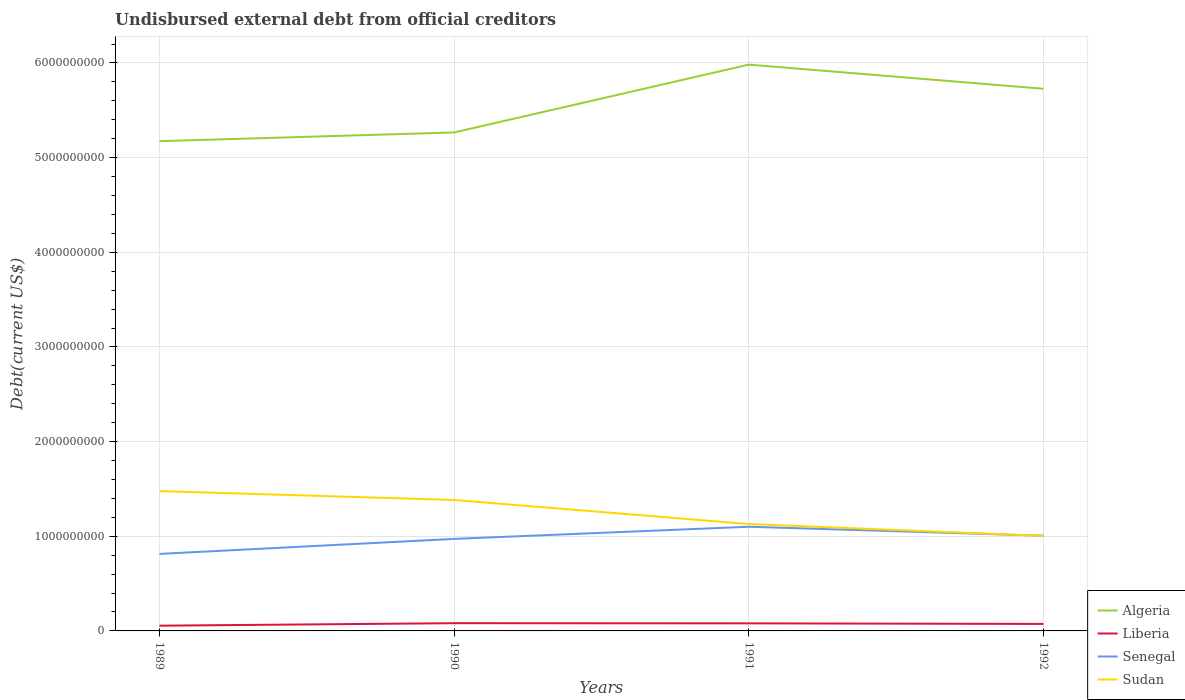Is the number of lines equal to the number of legend labels?
Make the answer very short. Yes. Across all years, what is the maximum total debt in Senegal?
Give a very brief answer. 8.14e+08. What is the total total debt in Senegal in the graph?
Ensure brevity in your answer.  -3.39e+07. What is the difference between the highest and the second highest total debt in Liberia?
Your answer should be compact. 2.63e+07. Is the total debt in Sudan strictly greater than the total debt in Senegal over the years?
Your answer should be very brief. No. Does the graph contain grids?
Offer a very short reply. Yes. Where does the legend appear in the graph?
Offer a very short reply. Bottom right. How are the legend labels stacked?
Offer a terse response. Vertical. What is the title of the graph?
Give a very brief answer. Undisbursed external debt from official creditors. Does "Micronesia" appear as one of the legend labels in the graph?
Your response must be concise. No. What is the label or title of the X-axis?
Offer a very short reply. Years. What is the label or title of the Y-axis?
Keep it short and to the point. Debt(current US$). What is the Debt(current US$) of Algeria in 1989?
Your answer should be very brief. 5.17e+09. What is the Debt(current US$) in Liberia in 1989?
Provide a succinct answer. 5.53e+07. What is the Debt(current US$) of Senegal in 1989?
Offer a very short reply. 8.14e+08. What is the Debt(current US$) of Sudan in 1989?
Give a very brief answer. 1.48e+09. What is the Debt(current US$) of Algeria in 1990?
Make the answer very short. 5.27e+09. What is the Debt(current US$) of Liberia in 1990?
Your response must be concise. 8.16e+07. What is the Debt(current US$) in Senegal in 1990?
Offer a very short reply. 9.72e+08. What is the Debt(current US$) of Sudan in 1990?
Provide a short and direct response. 1.38e+09. What is the Debt(current US$) in Algeria in 1991?
Offer a very short reply. 5.98e+09. What is the Debt(current US$) of Liberia in 1991?
Provide a short and direct response. 8.01e+07. What is the Debt(current US$) of Senegal in 1991?
Ensure brevity in your answer.  1.10e+09. What is the Debt(current US$) in Sudan in 1991?
Your response must be concise. 1.13e+09. What is the Debt(current US$) of Algeria in 1992?
Offer a very short reply. 5.73e+09. What is the Debt(current US$) in Liberia in 1992?
Keep it short and to the point. 7.37e+07. What is the Debt(current US$) of Senegal in 1992?
Provide a succinct answer. 1.01e+09. What is the Debt(current US$) in Sudan in 1992?
Make the answer very short. 1.00e+09. Across all years, what is the maximum Debt(current US$) in Algeria?
Ensure brevity in your answer.  5.98e+09. Across all years, what is the maximum Debt(current US$) of Liberia?
Ensure brevity in your answer.  8.16e+07. Across all years, what is the maximum Debt(current US$) in Senegal?
Your response must be concise. 1.10e+09. Across all years, what is the maximum Debt(current US$) in Sudan?
Your response must be concise. 1.48e+09. Across all years, what is the minimum Debt(current US$) in Algeria?
Ensure brevity in your answer.  5.17e+09. Across all years, what is the minimum Debt(current US$) of Liberia?
Offer a terse response. 5.53e+07. Across all years, what is the minimum Debt(current US$) of Senegal?
Your answer should be compact. 8.14e+08. Across all years, what is the minimum Debt(current US$) of Sudan?
Make the answer very short. 1.00e+09. What is the total Debt(current US$) in Algeria in the graph?
Your answer should be compact. 2.22e+1. What is the total Debt(current US$) in Liberia in the graph?
Keep it short and to the point. 2.91e+08. What is the total Debt(current US$) in Senegal in the graph?
Ensure brevity in your answer.  3.89e+09. What is the total Debt(current US$) of Sudan in the graph?
Make the answer very short. 4.99e+09. What is the difference between the Debt(current US$) in Algeria in 1989 and that in 1990?
Your answer should be very brief. -9.20e+07. What is the difference between the Debt(current US$) of Liberia in 1989 and that in 1990?
Ensure brevity in your answer.  -2.63e+07. What is the difference between the Debt(current US$) of Senegal in 1989 and that in 1990?
Ensure brevity in your answer.  -1.59e+08. What is the difference between the Debt(current US$) in Sudan in 1989 and that in 1990?
Provide a short and direct response. 9.43e+07. What is the difference between the Debt(current US$) in Algeria in 1989 and that in 1991?
Give a very brief answer. -8.09e+08. What is the difference between the Debt(current US$) of Liberia in 1989 and that in 1991?
Keep it short and to the point. -2.47e+07. What is the difference between the Debt(current US$) in Senegal in 1989 and that in 1991?
Provide a short and direct response. -2.87e+08. What is the difference between the Debt(current US$) in Sudan in 1989 and that in 1991?
Keep it short and to the point. 3.48e+08. What is the difference between the Debt(current US$) in Algeria in 1989 and that in 1992?
Keep it short and to the point. -5.54e+08. What is the difference between the Debt(current US$) in Liberia in 1989 and that in 1992?
Provide a succinct answer. -1.84e+07. What is the difference between the Debt(current US$) in Senegal in 1989 and that in 1992?
Offer a very short reply. -1.92e+08. What is the difference between the Debt(current US$) in Sudan in 1989 and that in 1992?
Make the answer very short. 4.74e+08. What is the difference between the Debt(current US$) of Algeria in 1990 and that in 1991?
Your answer should be compact. -7.17e+08. What is the difference between the Debt(current US$) of Liberia in 1990 and that in 1991?
Give a very brief answer. 1.58e+06. What is the difference between the Debt(current US$) in Senegal in 1990 and that in 1991?
Your answer should be very brief. -1.28e+08. What is the difference between the Debt(current US$) in Sudan in 1990 and that in 1991?
Give a very brief answer. 2.54e+08. What is the difference between the Debt(current US$) of Algeria in 1990 and that in 1992?
Provide a succinct answer. -4.62e+08. What is the difference between the Debt(current US$) of Liberia in 1990 and that in 1992?
Your answer should be very brief. 7.89e+06. What is the difference between the Debt(current US$) in Senegal in 1990 and that in 1992?
Keep it short and to the point. -3.39e+07. What is the difference between the Debt(current US$) of Sudan in 1990 and that in 1992?
Offer a terse response. 3.80e+08. What is the difference between the Debt(current US$) of Algeria in 1991 and that in 1992?
Give a very brief answer. 2.55e+08. What is the difference between the Debt(current US$) in Liberia in 1991 and that in 1992?
Ensure brevity in your answer.  6.30e+06. What is the difference between the Debt(current US$) in Senegal in 1991 and that in 1992?
Offer a very short reply. 9.45e+07. What is the difference between the Debt(current US$) of Sudan in 1991 and that in 1992?
Your answer should be very brief. 1.26e+08. What is the difference between the Debt(current US$) of Algeria in 1989 and the Debt(current US$) of Liberia in 1990?
Provide a succinct answer. 5.09e+09. What is the difference between the Debt(current US$) of Algeria in 1989 and the Debt(current US$) of Senegal in 1990?
Ensure brevity in your answer.  4.20e+09. What is the difference between the Debt(current US$) of Algeria in 1989 and the Debt(current US$) of Sudan in 1990?
Provide a short and direct response. 3.79e+09. What is the difference between the Debt(current US$) of Liberia in 1989 and the Debt(current US$) of Senegal in 1990?
Offer a very short reply. -9.17e+08. What is the difference between the Debt(current US$) of Liberia in 1989 and the Debt(current US$) of Sudan in 1990?
Provide a succinct answer. -1.33e+09. What is the difference between the Debt(current US$) in Senegal in 1989 and the Debt(current US$) in Sudan in 1990?
Make the answer very short. -5.70e+08. What is the difference between the Debt(current US$) in Algeria in 1989 and the Debt(current US$) in Liberia in 1991?
Make the answer very short. 5.09e+09. What is the difference between the Debt(current US$) in Algeria in 1989 and the Debt(current US$) in Senegal in 1991?
Make the answer very short. 4.07e+09. What is the difference between the Debt(current US$) of Algeria in 1989 and the Debt(current US$) of Sudan in 1991?
Give a very brief answer. 4.04e+09. What is the difference between the Debt(current US$) in Liberia in 1989 and the Debt(current US$) in Senegal in 1991?
Offer a very short reply. -1.05e+09. What is the difference between the Debt(current US$) of Liberia in 1989 and the Debt(current US$) of Sudan in 1991?
Ensure brevity in your answer.  -1.07e+09. What is the difference between the Debt(current US$) in Senegal in 1989 and the Debt(current US$) in Sudan in 1991?
Offer a very short reply. -3.16e+08. What is the difference between the Debt(current US$) of Algeria in 1989 and the Debt(current US$) of Liberia in 1992?
Provide a succinct answer. 5.10e+09. What is the difference between the Debt(current US$) of Algeria in 1989 and the Debt(current US$) of Senegal in 1992?
Your answer should be very brief. 4.17e+09. What is the difference between the Debt(current US$) of Algeria in 1989 and the Debt(current US$) of Sudan in 1992?
Your answer should be very brief. 4.17e+09. What is the difference between the Debt(current US$) in Liberia in 1989 and the Debt(current US$) in Senegal in 1992?
Offer a very short reply. -9.51e+08. What is the difference between the Debt(current US$) in Liberia in 1989 and the Debt(current US$) in Sudan in 1992?
Offer a terse response. -9.48e+08. What is the difference between the Debt(current US$) in Senegal in 1989 and the Debt(current US$) in Sudan in 1992?
Offer a terse response. -1.90e+08. What is the difference between the Debt(current US$) in Algeria in 1990 and the Debt(current US$) in Liberia in 1991?
Your response must be concise. 5.19e+09. What is the difference between the Debt(current US$) of Algeria in 1990 and the Debt(current US$) of Senegal in 1991?
Make the answer very short. 4.17e+09. What is the difference between the Debt(current US$) in Algeria in 1990 and the Debt(current US$) in Sudan in 1991?
Offer a terse response. 4.14e+09. What is the difference between the Debt(current US$) in Liberia in 1990 and the Debt(current US$) in Senegal in 1991?
Give a very brief answer. -1.02e+09. What is the difference between the Debt(current US$) of Liberia in 1990 and the Debt(current US$) of Sudan in 1991?
Keep it short and to the point. -1.05e+09. What is the difference between the Debt(current US$) of Senegal in 1990 and the Debt(current US$) of Sudan in 1991?
Offer a terse response. -1.57e+08. What is the difference between the Debt(current US$) in Algeria in 1990 and the Debt(current US$) in Liberia in 1992?
Your answer should be very brief. 5.19e+09. What is the difference between the Debt(current US$) in Algeria in 1990 and the Debt(current US$) in Senegal in 1992?
Give a very brief answer. 4.26e+09. What is the difference between the Debt(current US$) of Algeria in 1990 and the Debt(current US$) of Sudan in 1992?
Ensure brevity in your answer.  4.26e+09. What is the difference between the Debt(current US$) in Liberia in 1990 and the Debt(current US$) in Senegal in 1992?
Offer a terse response. -9.24e+08. What is the difference between the Debt(current US$) in Liberia in 1990 and the Debt(current US$) in Sudan in 1992?
Give a very brief answer. -9.22e+08. What is the difference between the Debt(current US$) in Senegal in 1990 and the Debt(current US$) in Sudan in 1992?
Give a very brief answer. -3.13e+07. What is the difference between the Debt(current US$) in Algeria in 1991 and the Debt(current US$) in Liberia in 1992?
Offer a very short reply. 5.91e+09. What is the difference between the Debt(current US$) in Algeria in 1991 and the Debt(current US$) in Senegal in 1992?
Offer a terse response. 4.98e+09. What is the difference between the Debt(current US$) in Algeria in 1991 and the Debt(current US$) in Sudan in 1992?
Provide a succinct answer. 4.98e+09. What is the difference between the Debt(current US$) of Liberia in 1991 and the Debt(current US$) of Senegal in 1992?
Your answer should be very brief. -9.26e+08. What is the difference between the Debt(current US$) in Liberia in 1991 and the Debt(current US$) in Sudan in 1992?
Your response must be concise. -9.23e+08. What is the difference between the Debt(current US$) in Senegal in 1991 and the Debt(current US$) in Sudan in 1992?
Offer a terse response. 9.71e+07. What is the average Debt(current US$) in Algeria per year?
Keep it short and to the point. 5.54e+09. What is the average Debt(current US$) of Liberia per year?
Ensure brevity in your answer.  7.27e+07. What is the average Debt(current US$) of Senegal per year?
Keep it short and to the point. 9.73e+08. What is the average Debt(current US$) in Sudan per year?
Provide a succinct answer. 1.25e+09. In the year 1989, what is the difference between the Debt(current US$) in Algeria and Debt(current US$) in Liberia?
Give a very brief answer. 5.12e+09. In the year 1989, what is the difference between the Debt(current US$) of Algeria and Debt(current US$) of Senegal?
Keep it short and to the point. 4.36e+09. In the year 1989, what is the difference between the Debt(current US$) in Algeria and Debt(current US$) in Sudan?
Keep it short and to the point. 3.70e+09. In the year 1989, what is the difference between the Debt(current US$) in Liberia and Debt(current US$) in Senegal?
Make the answer very short. -7.58e+08. In the year 1989, what is the difference between the Debt(current US$) of Liberia and Debt(current US$) of Sudan?
Your answer should be compact. -1.42e+09. In the year 1989, what is the difference between the Debt(current US$) of Senegal and Debt(current US$) of Sudan?
Offer a very short reply. -6.64e+08. In the year 1990, what is the difference between the Debt(current US$) in Algeria and Debt(current US$) in Liberia?
Provide a succinct answer. 5.18e+09. In the year 1990, what is the difference between the Debt(current US$) in Algeria and Debt(current US$) in Senegal?
Ensure brevity in your answer.  4.29e+09. In the year 1990, what is the difference between the Debt(current US$) of Algeria and Debt(current US$) of Sudan?
Keep it short and to the point. 3.88e+09. In the year 1990, what is the difference between the Debt(current US$) in Liberia and Debt(current US$) in Senegal?
Offer a very short reply. -8.91e+08. In the year 1990, what is the difference between the Debt(current US$) in Liberia and Debt(current US$) in Sudan?
Provide a succinct answer. -1.30e+09. In the year 1990, what is the difference between the Debt(current US$) of Senegal and Debt(current US$) of Sudan?
Ensure brevity in your answer.  -4.11e+08. In the year 1991, what is the difference between the Debt(current US$) of Algeria and Debt(current US$) of Liberia?
Your response must be concise. 5.90e+09. In the year 1991, what is the difference between the Debt(current US$) in Algeria and Debt(current US$) in Senegal?
Offer a terse response. 4.88e+09. In the year 1991, what is the difference between the Debt(current US$) of Algeria and Debt(current US$) of Sudan?
Provide a succinct answer. 4.85e+09. In the year 1991, what is the difference between the Debt(current US$) of Liberia and Debt(current US$) of Senegal?
Provide a succinct answer. -1.02e+09. In the year 1991, what is the difference between the Debt(current US$) of Liberia and Debt(current US$) of Sudan?
Offer a terse response. -1.05e+09. In the year 1991, what is the difference between the Debt(current US$) in Senegal and Debt(current US$) in Sudan?
Provide a short and direct response. -2.89e+07. In the year 1992, what is the difference between the Debt(current US$) in Algeria and Debt(current US$) in Liberia?
Your answer should be very brief. 5.65e+09. In the year 1992, what is the difference between the Debt(current US$) of Algeria and Debt(current US$) of Senegal?
Keep it short and to the point. 4.72e+09. In the year 1992, what is the difference between the Debt(current US$) in Algeria and Debt(current US$) in Sudan?
Give a very brief answer. 4.72e+09. In the year 1992, what is the difference between the Debt(current US$) in Liberia and Debt(current US$) in Senegal?
Provide a short and direct response. -9.32e+08. In the year 1992, what is the difference between the Debt(current US$) of Liberia and Debt(current US$) of Sudan?
Provide a short and direct response. -9.30e+08. In the year 1992, what is the difference between the Debt(current US$) in Senegal and Debt(current US$) in Sudan?
Offer a very short reply. 2.57e+06. What is the ratio of the Debt(current US$) of Algeria in 1989 to that in 1990?
Make the answer very short. 0.98. What is the ratio of the Debt(current US$) of Liberia in 1989 to that in 1990?
Your answer should be compact. 0.68. What is the ratio of the Debt(current US$) of Senegal in 1989 to that in 1990?
Make the answer very short. 0.84. What is the ratio of the Debt(current US$) in Sudan in 1989 to that in 1990?
Provide a short and direct response. 1.07. What is the ratio of the Debt(current US$) of Algeria in 1989 to that in 1991?
Your response must be concise. 0.86. What is the ratio of the Debt(current US$) of Liberia in 1989 to that in 1991?
Provide a short and direct response. 0.69. What is the ratio of the Debt(current US$) of Senegal in 1989 to that in 1991?
Your answer should be very brief. 0.74. What is the ratio of the Debt(current US$) in Sudan in 1989 to that in 1991?
Give a very brief answer. 1.31. What is the ratio of the Debt(current US$) in Algeria in 1989 to that in 1992?
Your answer should be compact. 0.9. What is the ratio of the Debt(current US$) of Liberia in 1989 to that in 1992?
Make the answer very short. 0.75. What is the ratio of the Debt(current US$) of Senegal in 1989 to that in 1992?
Your response must be concise. 0.81. What is the ratio of the Debt(current US$) of Sudan in 1989 to that in 1992?
Ensure brevity in your answer.  1.47. What is the ratio of the Debt(current US$) in Algeria in 1990 to that in 1991?
Your response must be concise. 0.88. What is the ratio of the Debt(current US$) in Liberia in 1990 to that in 1991?
Make the answer very short. 1.02. What is the ratio of the Debt(current US$) of Senegal in 1990 to that in 1991?
Offer a terse response. 0.88. What is the ratio of the Debt(current US$) of Sudan in 1990 to that in 1991?
Keep it short and to the point. 1.22. What is the ratio of the Debt(current US$) of Algeria in 1990 to that in 1992?
Provide a succinct answer. 0.92. What is the ratio of the Debt(current US$) in Liberia in 1990 to that in 1992?
Provide a short and direct response. 1.11. What is the ratio of the Debt(current US$) in Senegal in 1990 to that in 1992?
Keep it short and to the point. 0.97. What is the ratio of the Debt(current US$) in Sudan in 1990 to that in 1992?
Your answer should be compact. 1.38. What is the ratio of the Debt(current US$) of Algeria in 1991 to that in 1992?
Give a very brief answer. 1.04. What is the ratio of the Debt(current US$) of Liberia in 1991 to that in 1992?
Offer a terse response. 1.09. What is the ratio of the Debt(current US$) in Senegal in 1991 to that in 1992?
Your response must be concise. 1.09. What is the ratio of the Debt(current US$) of Sudan in 1991 to that in 1992?
Provide a short and direct response. 1.13. What is the difference between the highest and the second highest Debt(current US$) in Algeria?
Give a very brief answer. 2.55e+08. What is the difference between the highest and the second highest Debt(current US$) in Liberia?
Offer a terse response. 1.58e+06. What is the difference between the highest and the second highest Debt(current US$) of Senegal?
Offer a very short reply. 9.45e+07. What is the difference between the highest and the second highest Debt(current US$) in Sudan?
Your answer should be compact. 9.43e+07. What is the difference between the highest and the lowest Debt(current US$) in Algeria?
Your answer should be compact. 8.09e+08. What is the difference between the highest and the lowest Debt(current US$) of Liberia?
Make the answer very short. 2.63e+07. What is the difference between the highest and the lowest Debt(current US$) in Senegal?
Your answer should be compact. 2.87e+08. What is the difference between the highest and the lowest Debt(current US$) of Sudan?
Provide a succinct answer. 4.74e+08. 